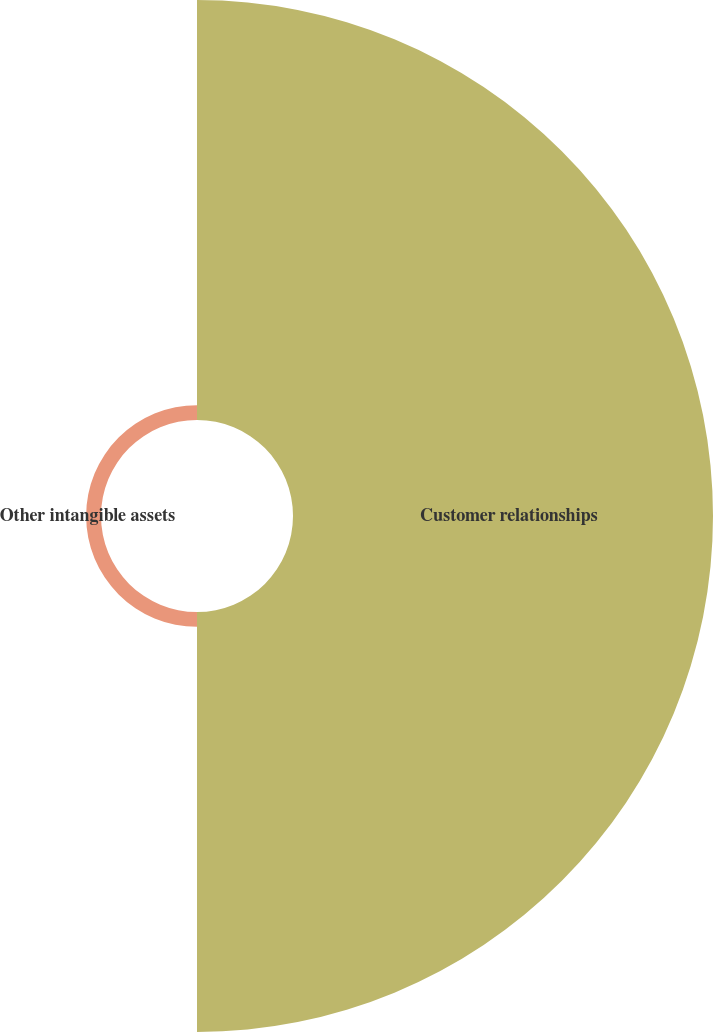Convert chart to OTSL. <chart><loc_0><loc_0><loc_500><loc_500><pie_chart><fcel>Customer relationships<fcel>Other intangible assets<nl><fcel>96.58%<fcel>3.42%<nl></chart> 